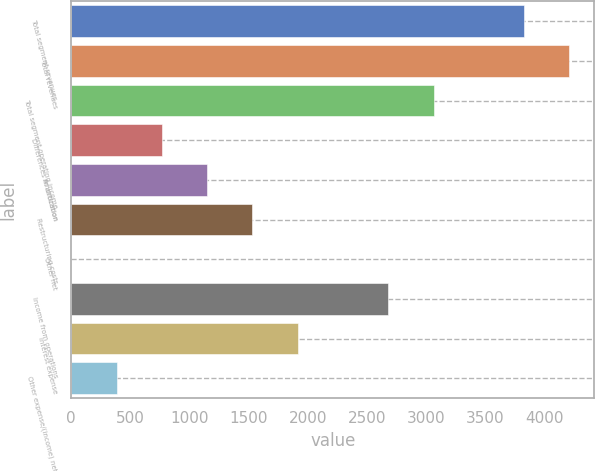<chart> <loc_0><loc_0><loc_500><loc_500><bar_chart><fcel>Total segment revenues<fcel>Total revenues<fcel>Total segment operating income<fcel>Differences in allocation<fcel>Amortization<fcel>Restructuring costs<fcel>Other net<fcel>Income from operations<fcel>Interest expense<fcel>Other expense/(income) net<nl><fcel>3829<fcel>4211.8<fcel>3063.4<fcel>766.6<fcel>1149.4<fcel>1532.2<fcel>1<fcel>2680.6<fcel>1915<fcel>383.8<nl></chart> 